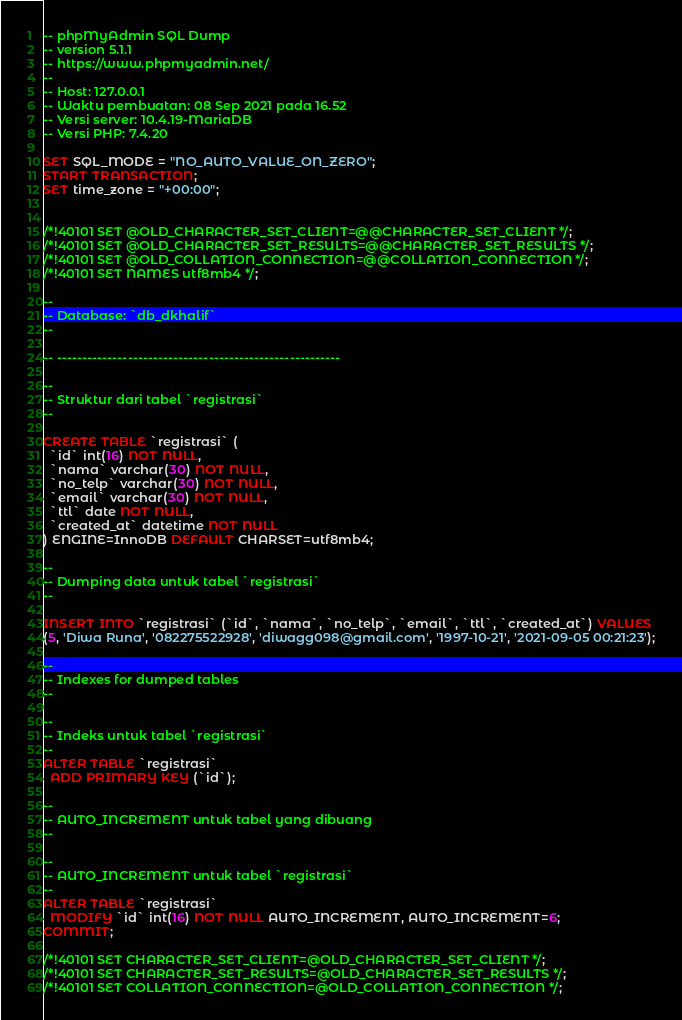Convert code to text. <code><loc_0><loc_0><loc_500><loc_500><_SQL_>-- phpMyAdmin SQL Dump
-- version 5.1.1
-- https://www.phpmyadmin.net/
--
-- Host: 127.0.0.1
-- Waktu pembuatan: 08 Sep 2021 pada 16.52
-- Versi server: 10.4.19-MariaDB
-- Versi PHP: 7.4.20

SET SQL_MODE = "NO_AUTO_VALUE_ON_ZERO";
START TRANSACTION;
SET time_zone = "+00:00";


/*!40101 SET @OLD_CHARACTER_SET_CLIENT=@@CHARACTER_SET_CLIENT */;
/*!40101 SET @OLD_CHARACTER_SET_RESULTS=@@CHARACTER_SET_RESULTS */;
/*!40101 SET @OLD_COLLATION_CONNECTION=@@COLLATION_CONNECTION */;
/*!40101 SET NAMES utf8mb4 */;

--
-- Database: `db_dkhalif`
--

-- --------------------------------------------------------

--
-- Struktur dari tabel `registrasi`
--

CREATE TABLE `registrasi` (
  `id` int(16) NOT NULL,
  `nama` varchar(30) NOT NULL,
  `no_telp` varchar(30) NOT NULL,
  `email` varchar(30) NOT NULL,
  `ttl` date NOT NULL,
  `created_at` datetime NOT NULL
) ENGINE=InnoDB DEFAULT CHARSET=utf8mb4;

--
-- Dumping data untuk tabel `registrasi`
--

INSERT INTO `registrasi` (`id`, `nama`, `no_telp`, `email`, `ttl`, `created_at`) VALUES
(5, 'Diwa Runa', '082275522928', 'diwagg098@gmail.com', '1997-10-21', '2021-09-05 00:21:23');

--
-- Indexes for dumped tables
--

--
-- Indeks untuk tabel `registrasi`
--
ALTER TABLE `registrasi`
  ADD PRIMARY KEY (`id`);

--
-- AUTO_INCREMENT untuk tabel yang dibuang
--

--
-- AUTO_INCREMENT untuk tabel `registrasi`
--
ALTER TABLE `registrasi`
  MODIFY `id` int(16) NOT NULL AUTO_INCREMENT, AUTO_INCREMENT=6;
COMMIT;

/*!40101 SET CHARACTER_SET_CLIENT=@OLD_CHARACTER_SET_CLIENT */;
/*!40101 SET CHARACTER_SET_RESULTS=@OLD_CHARACTER_SET_RESULTS */;
/*!40101 SET COLLATION_CONNECTION=@OLD_COLLATION_CONNECTION */;
</code> 